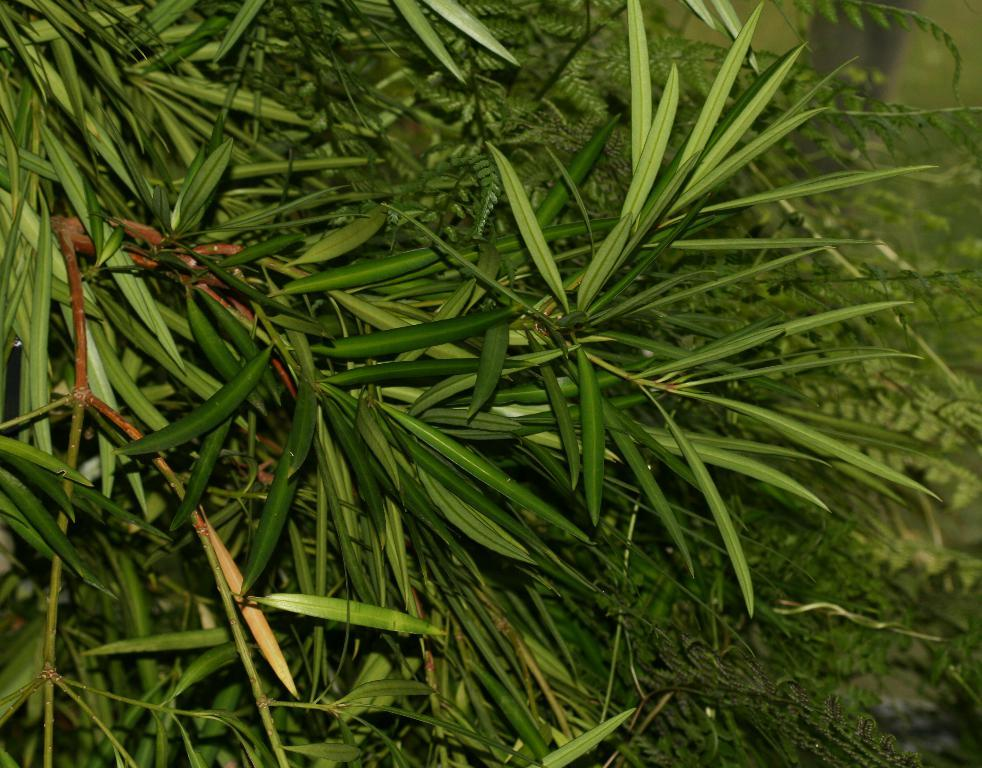What is the main subject of the image? The main subject of the image is a tree. What part of the tree can be seen in the image? The image is a zoomed-in view of the tree, so only a portion of it is visible. What can be observed on the tree in the image? There are leaves visible in the image. What type of committee is meeting at the top of the tree in the image? There is no committee meeting at the top of the tree in the image; it is a tree with leaves. How many mountains can be seen in the background of the image? There are no mountains visible in the image; it is a close-up view of a tree with leaves. 